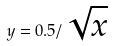Convert formula to latex. <formula><loc_0><loc_0><loc_500><loc_500>y = 0 . 5 / \sqrt { x }</formula> 